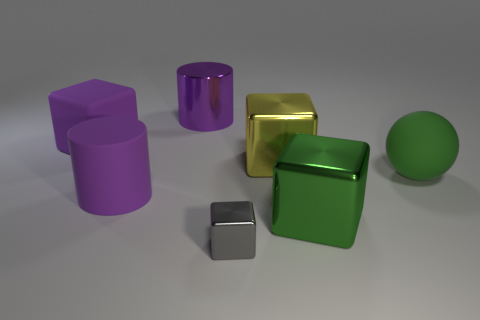Subtract all large green metallic blocks. How many blocks are left? 3 Subtract 1 cylinders. How many cylinders are left? 1 Subtract all purple cubes. How many cubes are left? 3 Add 2 large yellow metallic blocks. How many objects exist? 9 Subtract 0 gray cylinders. How many objects are left? 7 Subtract all balls. How many objects are left? 6 Subtract all purple balls. Subtract all red blocks. How many balls are left? 1 Subtract all large purple things. Subtract all large purple metallic objects. How many objects are left? 3 Add 5 large green metal objects. How many large green metal objects are left? 6 Add 4 cylinders. How many cylinders exist? 6 